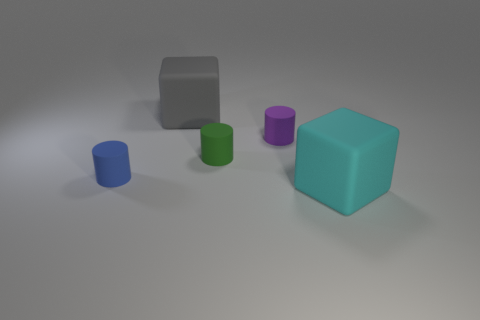Are there any small purple rubber spheres? no 